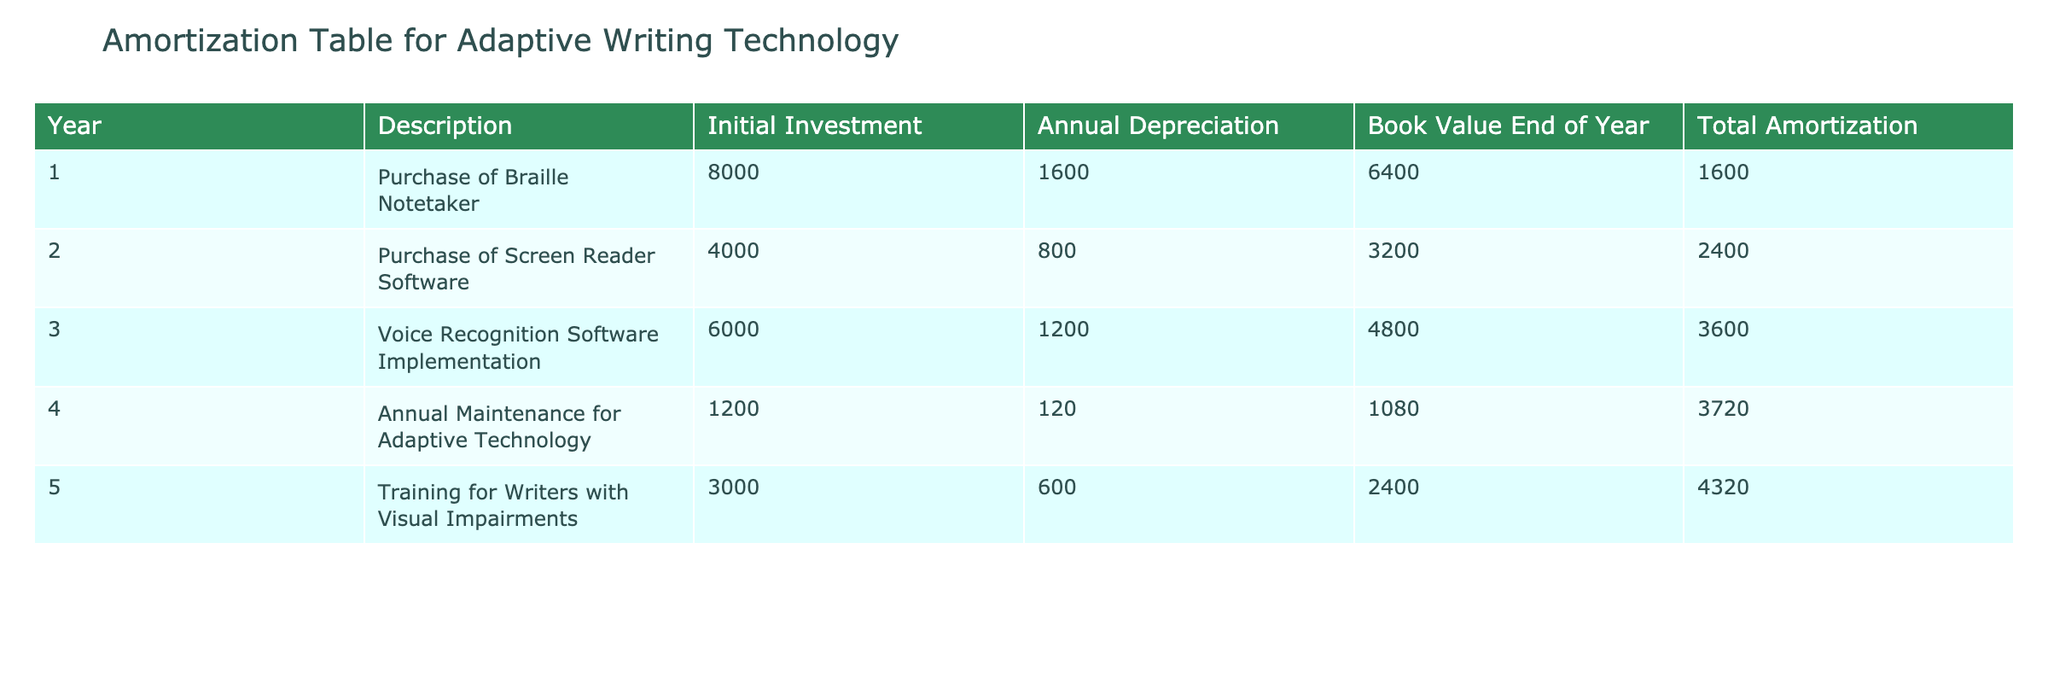What was the total initial investment for all the adaptive writing technologies listed? To find the total initial investment, add up the Initial Investment column values: 8000 + 4000 + 6000 + 1200 + 3000 = 22200.
Answer: 22200 Which technology had the highest annual depreciation? By comparing the Annual Depreciation values, we see that the Purchase of Braille Notetaker has the highest depreciation at 1600.
Answer: 1600 What is the book value of the Voice Recognition Software Implementation at the end of year 3? The book value at the end of year 3 is listed in the table as 4800.
Answer: 4800 Is the total amortization for the Training for Writers with Visual Impairments greater than 4000? The total amortization for Training for Writers with Visual Impairments is 4320, which is greater than 4000. Thus, the answer is yes.
Answer: Yes What is the total amortization for all investments at the end of year 5? To find the total amortization, sum the Total Amortization column: 1600 + 2400 + 3600 + 3720 + 4320 = 15640.
Answer: 15640 What was the total book value of the adaptive technologies at the end of year 2? To find this, we add the Book Value End of Year column for years 1 and 2: 6400 (year 1) + 3200 (year 2) = 9600.
Answer: 9600 Was the annual depreciation for the Screen Reader Software lower than that of the Voice Recognition Software? The Annual Depreciation for the Screen Reader Software is 800 and for Voice Recognition Software it is 1200, so the Screen Reader Software's depreciation is indeed lower.
Answer: Yes What is the average annual depreciation for the five adaptive technologies? To calculate the average, sum all the annual depreciations: 1600 + 800 + 1200 + 120 + 600 = 3820. There are 5 technologies, so the average is 3820 / 5 = 764.
Answer: 764 If we consider only the adaptive technology purchases (excluding maintenance and training), what is the total amortization at the end of year 4? We only consider the initial investments terms related to purchase: Braille Notetaker, Screen Reader Software, and Voice Recognition Software, giving us 1600 (year 1) + 2400 (year 2) + 3600 (year 3)+ 3720 (year 4) = 11200.
Answer: 11200 